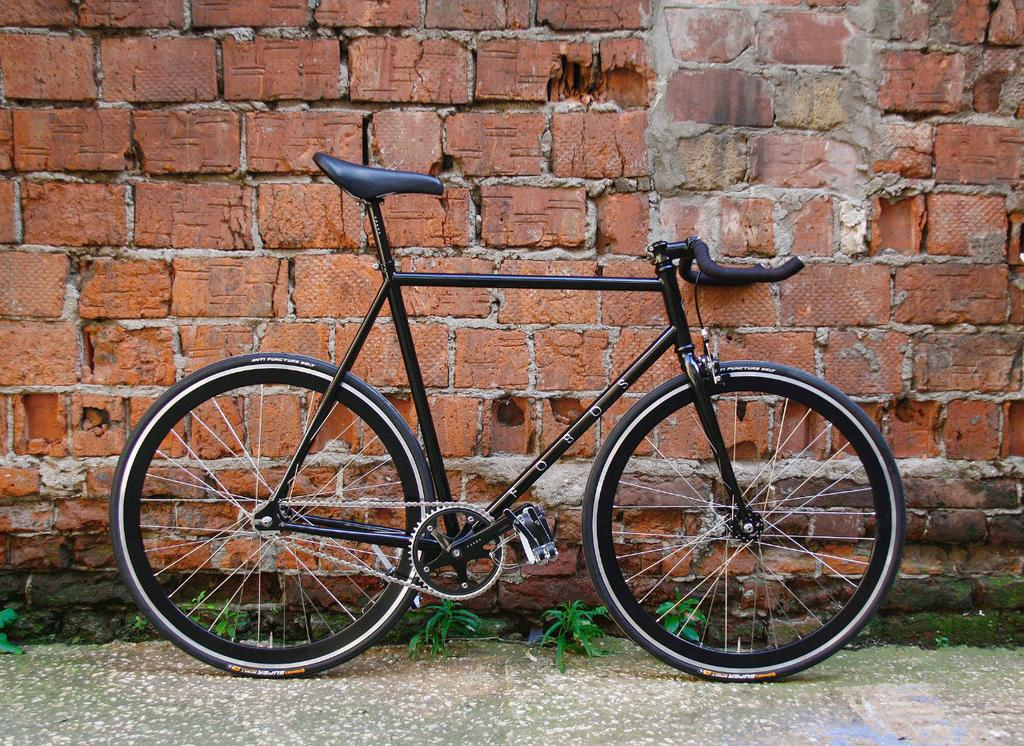What is the main object in the image? There is a bicycle in the image. Where is the bicycle located in relation to other objects? The bicycle is near a wall. What type of vegetation can be seen in the image? There are plants on the ground in the image. What type of pain is the bicycle experiencing in the image? The bicycle is not experiencing any pain in the image, as it is an inanimate object. 